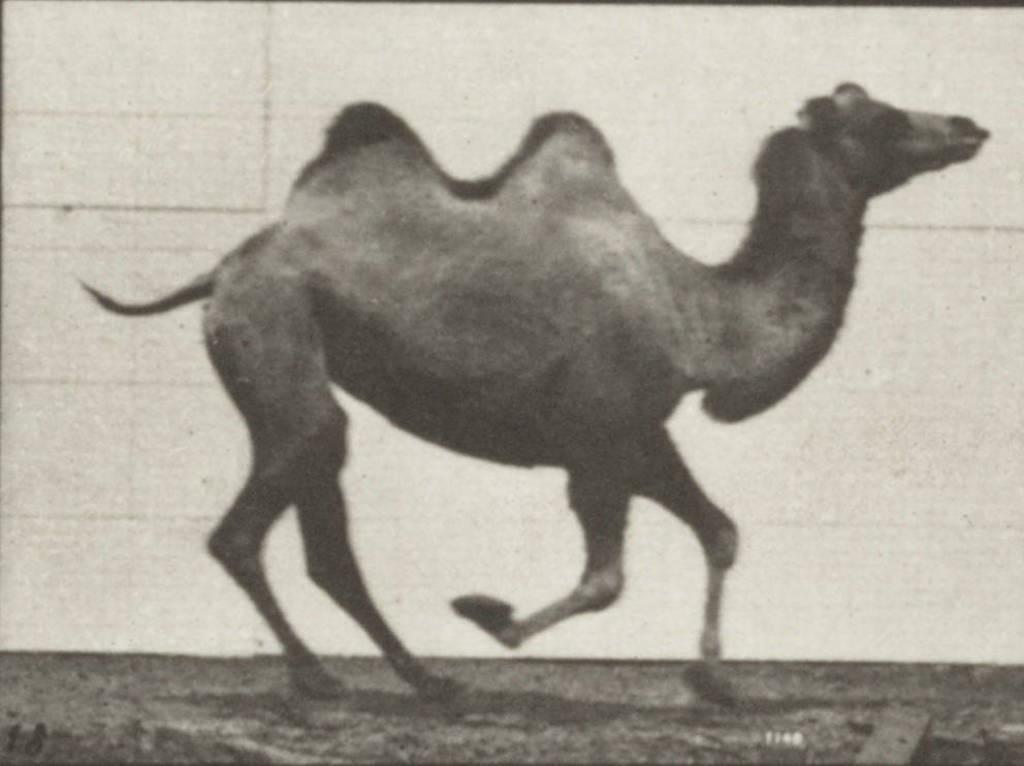Describe this image in one or two sentences. In this image we can see there is a camel running on road. 